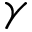<formula> <loc_0><loc_0><loc_500><loc_500>\gamma</formula> 